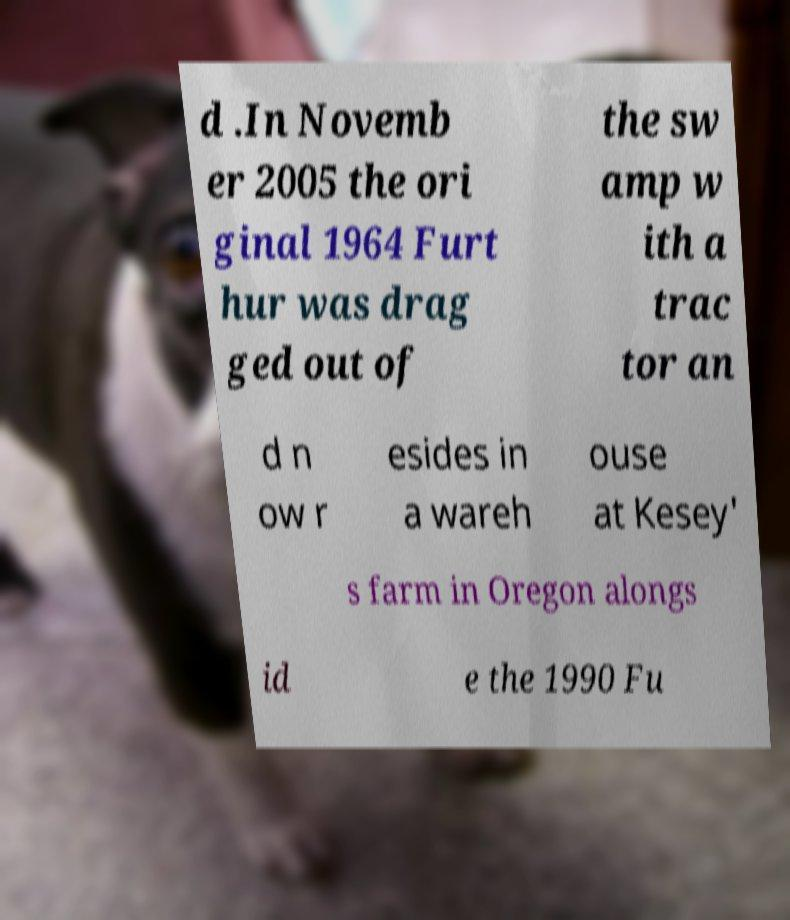Could you extract and type out the text from this image? d .In Novemb er 2005 the ori ginal 1964 Furt hur was drag ged out of the sw amp w ith a trac tor an d n ow r esides in a wareh ouse at Kesey' s farm in Oregon alongs id e the 1990 Fu 